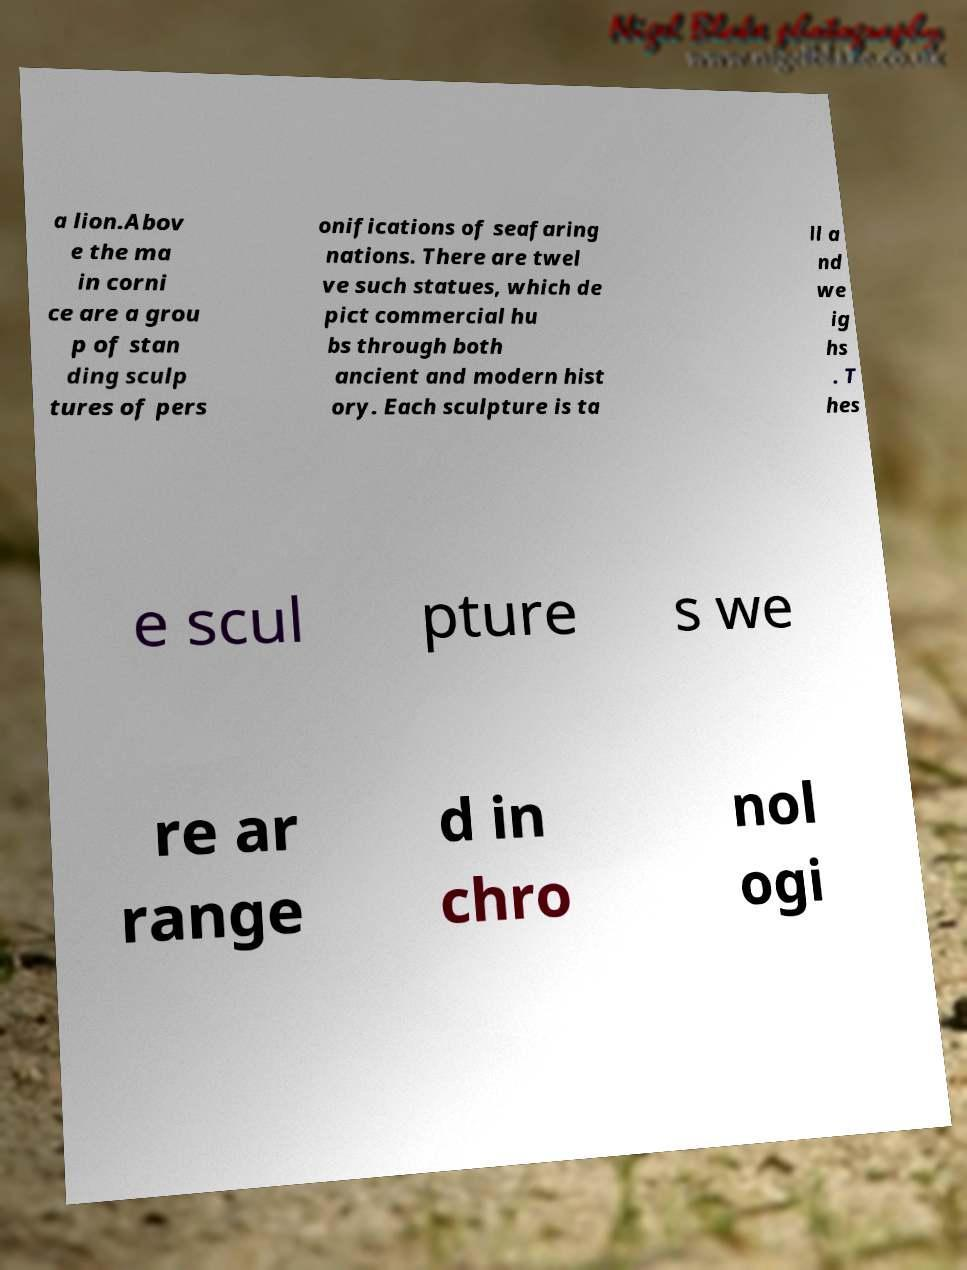I need the written content from this picture converted into text. Can you do that? a lion.Abov e the ma in corni ce are a grou p of stan ding sculp tures of pers onifications of seafaring nations. There are twel ve such statues, which de pict commercial hu bs through both ancient and modern hist ory. Each sculpture is ta ll a nd we ig hs . T hes e scul pture s we re ar range d in chro nol ogi 